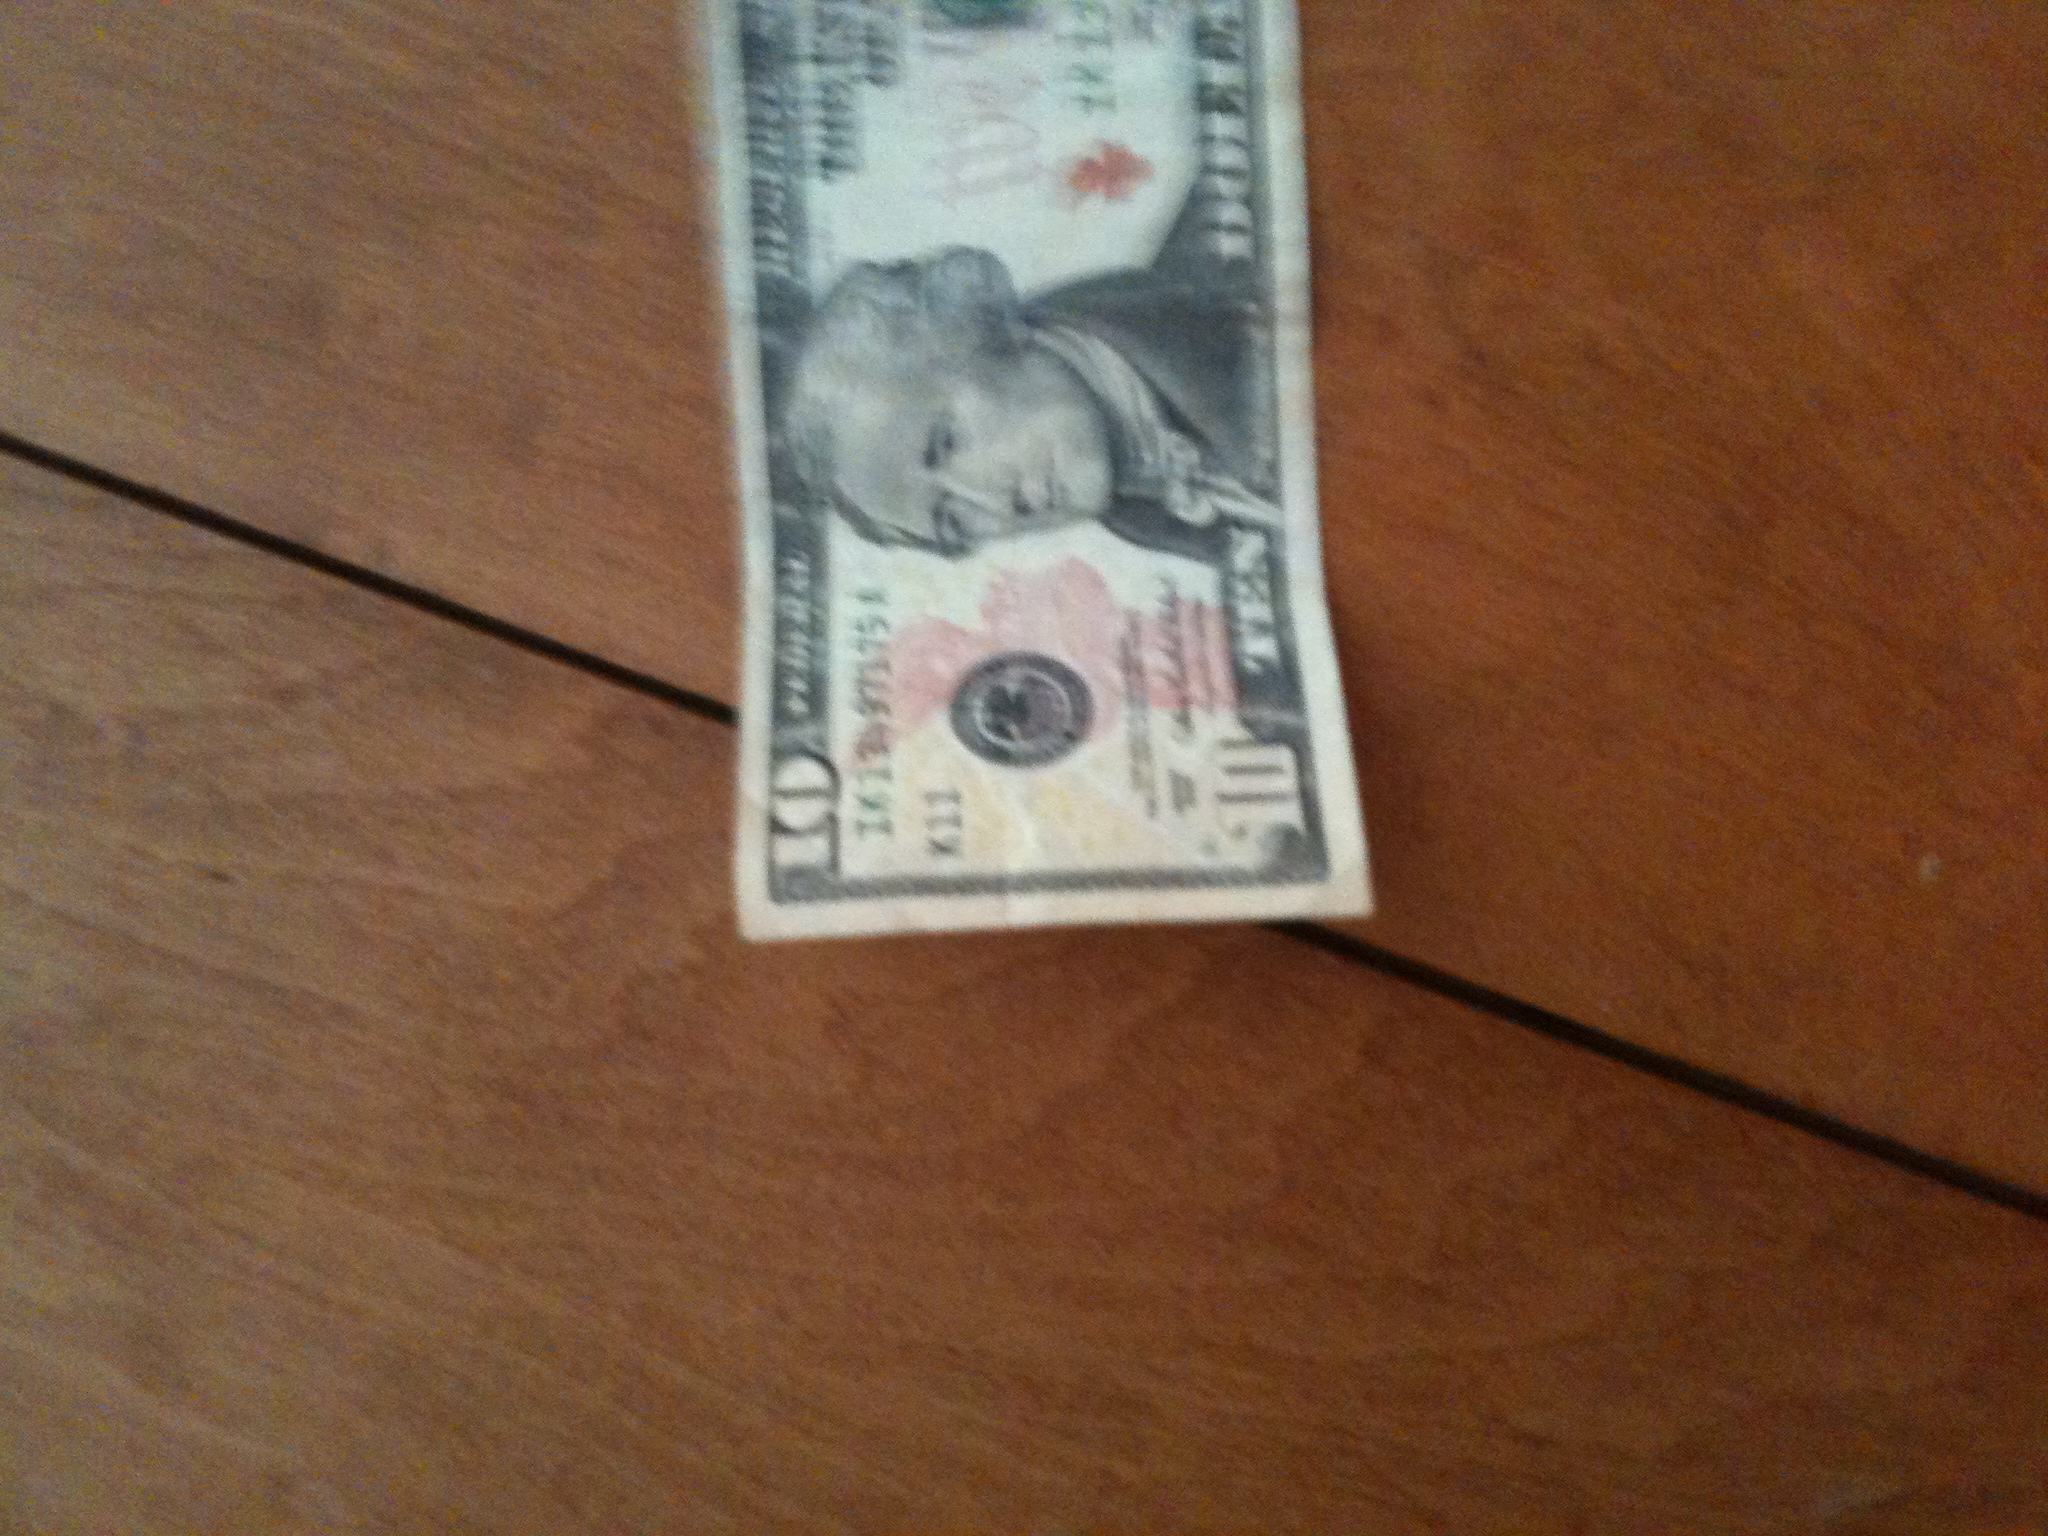Can you imagine a fictional scenario where this bill has magical properties? Imagine a world where this 10-dollar bill grants its holder the ability to travel back in time. Each time it is used for a transaction, both the buyer and seller are transported to any historical period, witnessing or even influencing events. This magical artifact could be the key to uncovering long-lost secrets of history or altering the course of past events subtly. The bill passes from hand to hand, carrying with it the power to reshape history as we know it. 